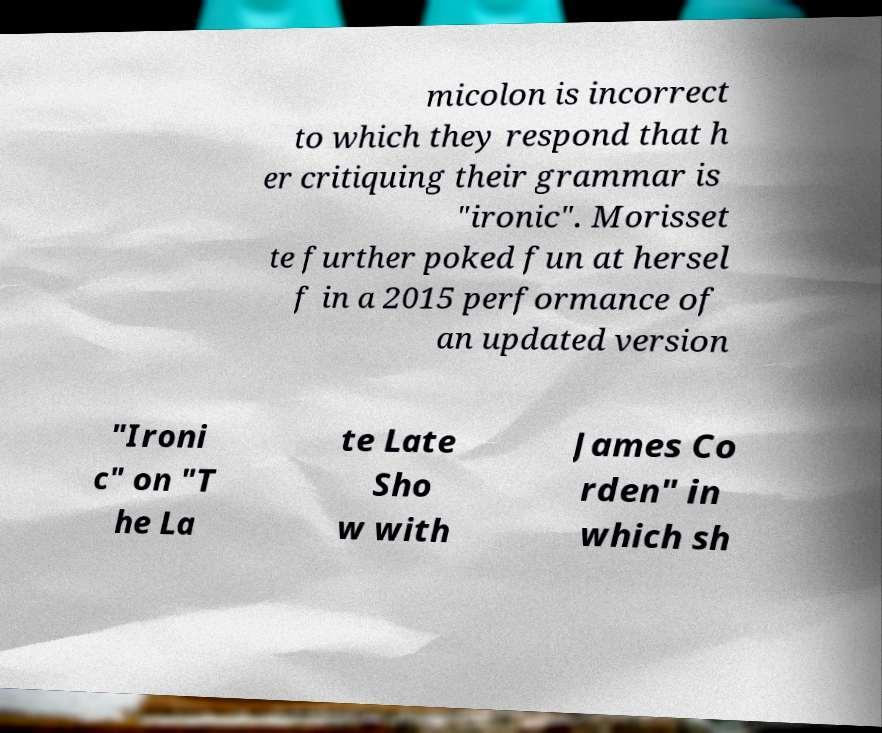I need the written content from this picture converted into text. Can you do that? micolon is incorrect to which they respond that h er critiquing their grammar is "ironic". Morisset te further poked fun at hersel f in a 2015 performance of an updated version "Ironi c" on "T he La te Late Sho w with James Co rden" in which sh 